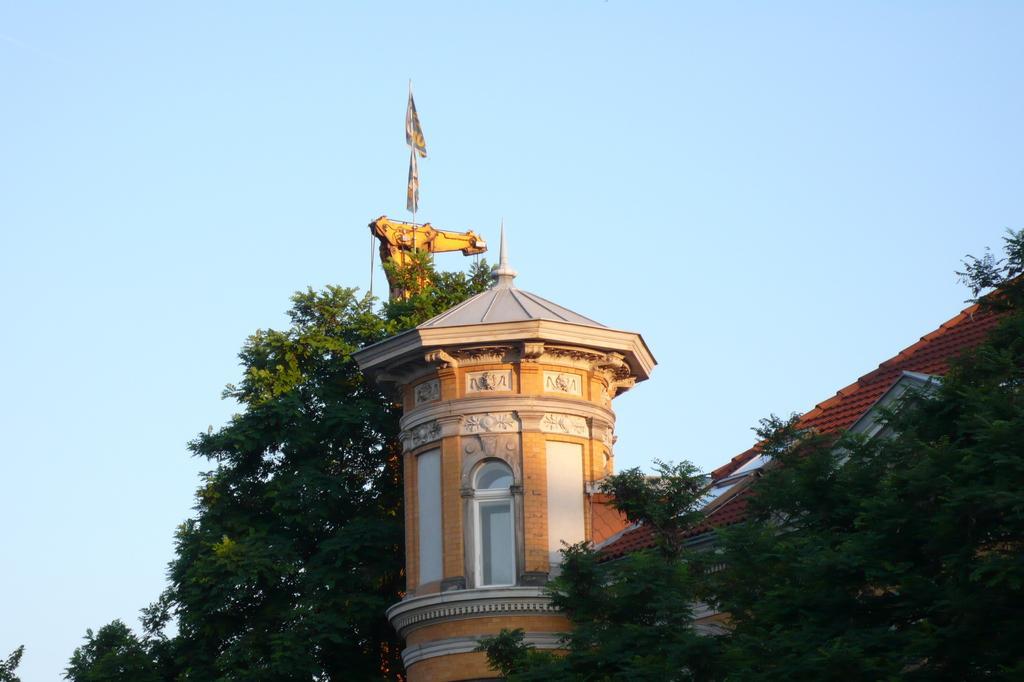Please provide a concise description of this image. On the right side of the image there is a building and trees. In the background there is a sky. 